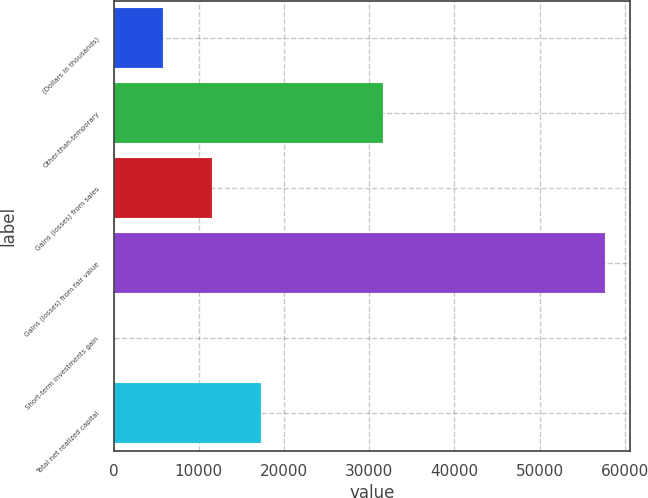<chart> <loc_0><loc_0><loc_500><loc_500><bar_chart><fcel>(Dollars in thousands)<fcel>Other-than-temporary<fcel>Gains (losses) from sales<fcel>Gains (losses) from fair value<fcel>Short-term investments gain<fcel>Total net realized capital<nl><fcel>5777.6<fcel>31595<fcel>11545.2<fcel>57686<fcel>10<fcel>17312.8<nl></chart> 